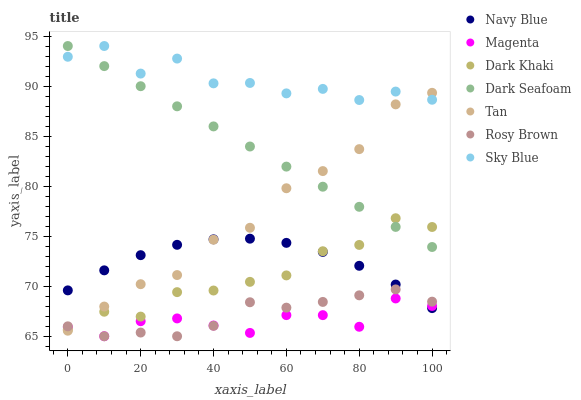Does Magenta have the minimum area under the curve?
Answer yes or no. Yes. Does Sky Blue have the maximum area under the curve?
Answer yes or no. Yes. Does Rosy Brown have the minimum area under the curve?
Answer yes or no. No. Does Rosy Brown have the maximum area under the curve?
Answer yes or no. No. Is Dark Seafoam the smoothest?
Answer yes or no. Yes. Is Sky Blue the roughest?
Answer yes or no. Yes. Is Rosy Brown the smoothest?
Answer yes or no. No. Is Rosy Brown the roughest?
Answer yes or no. No. Does Rosy Brown have the lowest value?
Answer yes or no. Yes. Does Dark Khaki have the lowest value?
Answer yes or no. No. Does Sky Blue have the highest value?
Answer yes or no. Yes. Does Rosy Brown have the highest value?
Answer yes or no. No. Is Rosy Brown less than Sky Blue?
Answer yes or no. Yes. Is Sky Blue greater than Magenta?
Answer yes or no. Yes. Does Rosy Brown intersect Tan?
Answer yes or no. Yes. Is Rosy Brown less than Tan?
Answer yes or no. No. Is Rosy Brown greater than Tan?
Answer yes or no. No. Does Rosy Brown intersect Sky Blue?
Answer yes or no. No. 